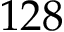Convert formula to latex. <formula><loc_0><loc_0><loc_500><loc_500>1 2 8</formula> 